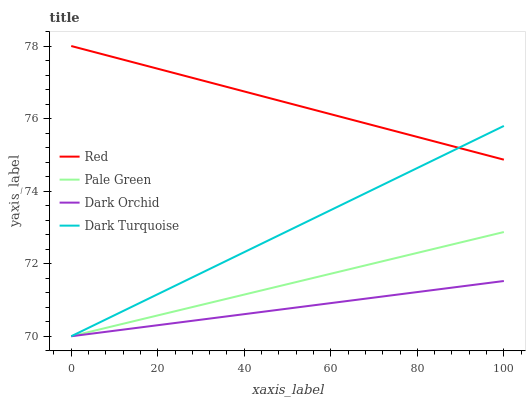Does Dark Orchid have the minimum area under the curve?
Answer yes or no. Yes. Does Red have the maximum area under the curve?
Answer yes or no. Yes. Does Pale Green have the minimum area under the curve?
Answer yes or no. No. Does Pale Green have the maximum area under the curve?
Answer yes or no. No. Is Pale Green the smoothest?
Answer yes or no. Yes. Is Dark Turquoise the roughest?
Answer yes or no. Yes. Is Dark Orchid the smoothest?
Answer yes or no. No. Is Dark Orchid the roughest?
Answer yes or no. No. Does Dark Turquoise have the lowest value?
Answer yes or no. Yes. Does Red have the lowest value?
Answer yes or no. No. Does Red have the highest value?
Answer yes or no. Yes. Does Pale Green have the highest value?
Answer yes or no. No. Is Pale Green less than Red?
Answer yes or no. Yes. Is Red greater than Dark Orchid?
Answer yes or no. Yes. Does Dark Turquoise intersect Pale Green?
Answer yes or no. Yes. Is Dark Turquoise less than Pale Green?
Answer yes or no. No. Is Dark Turquoise greater than Pale Green?
Answer yes or no. No. Does Pale Green intersect Red?
Answer yes or no. No. 